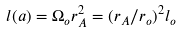Convert formula to latex. <formula><loc_0><loc_0><loc_500><loc_500>l ( a ) = \Omega _ { o } r _ { A } ^ { 2 } = ( r _ { A } / r _ { o } ) ^ { 2 } l _ { o }</formula> 